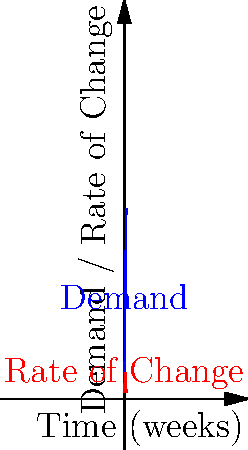As the director of operations, you're analyzing the demand curve for a new product launch. The blue curve represents the demand function $D(t) = \frac{1000}{1+e^{-0.5(t-5)}}$, where $t$ is time in weeks. The red curve shows the rate of change of demand. At which week is the rate of change of demand at its maximum, and what is this maximum rate? To solve this problem, we need to follow these steps:

1) The rate of change of demand is given by the derivative of the demand function:

   $$D'(t) = \frac{d}{dt}\left(\frac{1000}{1+e^{-0.5(t-5)}}\right)$$

2) Using the chain rule, we get:

   $$D'(t) = 1000 \cdot \frac{0.5e^{-0.5(t-5)}}{(1+e^{-0.5(t-5)})^2}$$

3) To find the maximum rate of change, we need to find where the second derivative equals zero:

   $$D''(t) = 500 \cdot \frac{0.5e^{-0.5(t-5)}(1+e^{-0.5(t-5)})^2 - 2(1+e^{-0.5(t-5)}) \cdot 0.5e^{-0.5(t-5)} \cdot 0.5e^{-0.5(t-5)}}{(1+e^{-0.5(t-5)})^4}$$

4) Setting this to zero and solving, we find that $D''(t) = 0$ when $t = 5$.

5) To confirm this is a maximum (not a minimum), we can check that $D'''(5) < 0$.

6) The maximum rate of change occurs at $t = 5$ weeks.

7) To find the value of the maximum rate, we evaluate $D'(5)$:

   $$D'(5) = 1000 \cdot \frac{0.5e^{-0.5(5-5)}}{(1+e^{-0.5(5-5)})^2} = 1000 \cdot \frac{0.5}{(1+1)^2} = 125$$

Therefore, the maximum rate of change occurs at week 5, and the maximum rate is 125 units per week.
Answer: Week 5; 125 units/week 